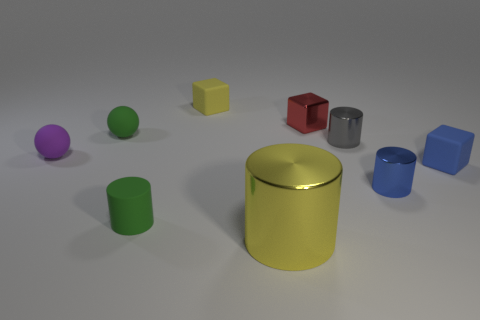Is there any other thing that has the same size as the yellow metallic object?
Provide a short and direct response. No. What number of other objects are there of the same material as the yellow cylinder?
Keep it short and to the point. 3. Are there any other things of the same color as the shiny cube?
Your response must be concise. No. There is another blue thing that is the same shape as the large object; what is it made of?
Provide a succinct answer. Metal. There is a yellow thing that is in front of the tiny purple thing; what is it made of?
Provide a short and direct response. Metal. There is a large metallic cylinder; does it have the same color as the matte block that is behind the small purple rubber sphere?
Your answer should be very brief. Yes. What number of objects are rubber objects that are left of the green matte cylinder or small green things in front of the small blue cylinder?
Offer a very short reply. 3. There is a tiny cube that is both left of the blue metallic cylinder and on the right side of the yellow cylinder; what color is it?
Your response must be concise. Red. Are there more purple balls than yellow shiny spheres?
Offer a terse response. Yes. Is the shape of the tiny green object behind the blue metal object the same as  the yellow matte object?
Your answer should be very brief. No. 